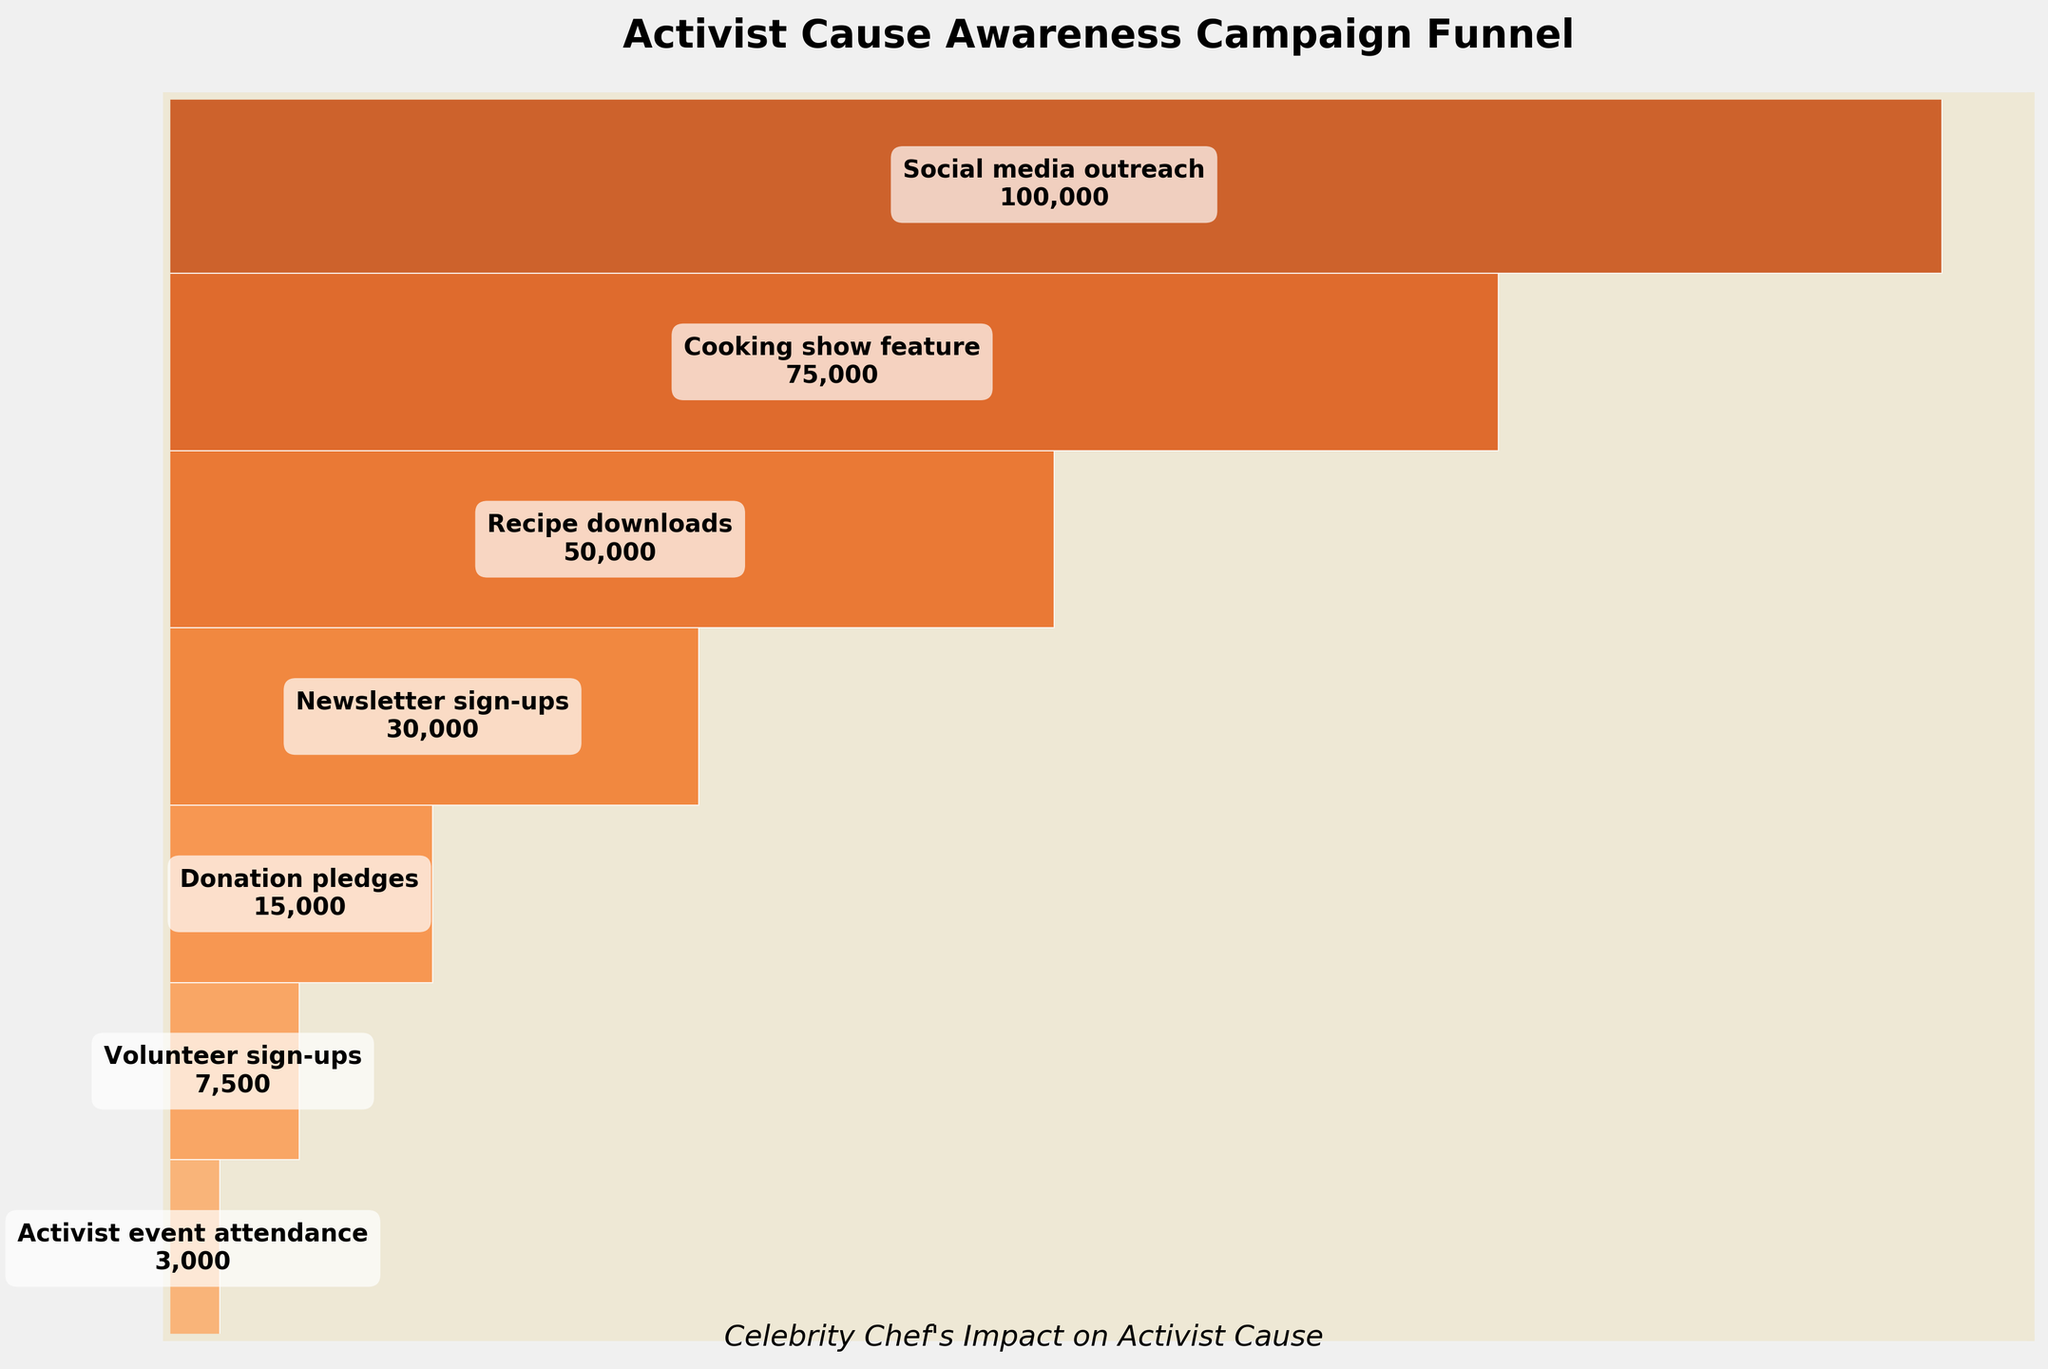What's the title of the figure? The title is prominently displayed at the top center of the figure. The title provides a summary of what the figure represents.
Answer: Activist Cause Awareness Campaign Funnel What is the first step in the funnel and how many participants are there in this step? The funnel starts from the top and moves downward through the steps. The first step is at the widest part of the funnel.
Answer: Social media outreach, 100,000 participants What is the average number of participants from 'Recipe downloads' to 'Volunteer sign-ups'? Adding the number of participants for the steps 'Recipe downloads', 'Newsletter sign-ups', 'Donation pledges', and 'Volunteer sign-ups' and dividing by 4. \( (50000 + 30000 + 15000 + 7500) / 4 \)
Answer: 25,625 Which step saw the largest decrease in participants compared to the previous step? By looking at the numbers and visual gaps between each step, we find the largest drop. The biggest difference would be between subsequent steps.
Answer: Cooking show feature to Recipe downloads, 25,000 decline Which step has the fewest participants? The smallest value shown in the figure is located at the bottom of the funnel.
Answer: Activist event attendance, 3,000 participants Which color palette is used in the chart and how does it affect the visualization? The colors used vary in shades of orange which helps create a visual cue of progression and intensity as participants decrease.
Answer: Oranges color palette What percentage of participants moved from 'Newsletter sign-ups' to 'Volunteer sign-ups'? Find the ratio of 'Volunteer sign-ups' to 'Newsletter sign-ups' and convert it to a percentage. \( 7500 / 30000 \times 100 \)
Answer: 25% By how much did the number of participants increase from 'Donation pledges' to 'Recipe downloads'? Calculating the difference between 'Recipe downloads' and 'Donation pledges'. \( 50000 - 15000 \)
Answer: 35,000 increase What's the total number of participants across all steps? Summing up the participants at each step. \( 100000 + 75000 + 50000 + 30000 + 15000 + 7500 + 3000 \)
Answer: 280,500 What unique insight can you gain about participant engagement from the shape of the funnel? The tapering shape indicates that participant engagement significantly drops at each step, suggesting a need for strategies to retain participation through the campaign stages.
Answer: Significant drop in engagement 